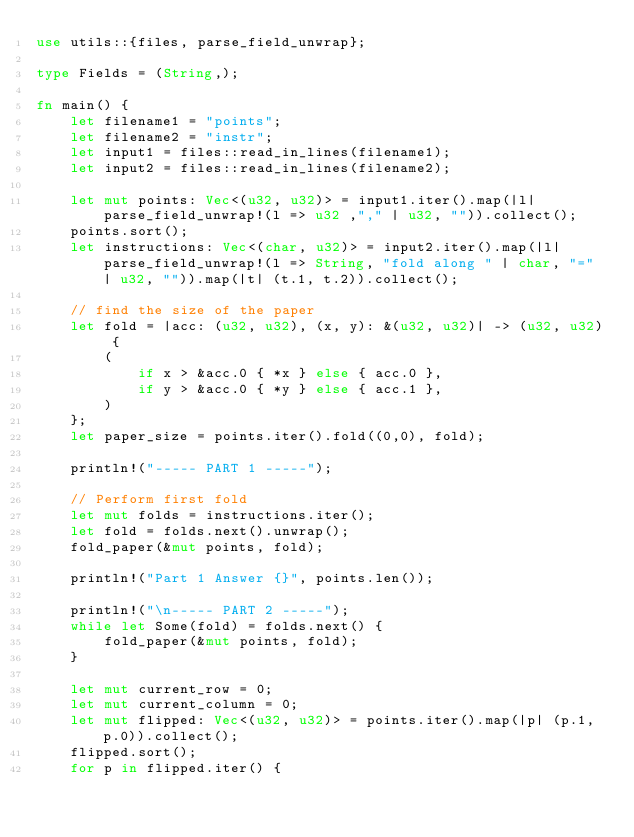<code> <loc_0><loc_0><loc_500><loc_500><_Rust_>use utils::{files, parse_field_unwrap};

type Fields = (String,);

fn main() {
    let filename1 = "points";
    let filename2 = "instr";
    let input1 = files::read_in_lines(filename1);
    let input2 = files::read_in_lines(filename2);

    let mut points: Vec<(u32, u32)> = input1.iter().map(|l| parse_field_unwrap!(l => u32 ,"," | u32, "")).collect();
    points.sort();
    let instructions: Vec<(char, u32)> = input2.iter().map(|l| parse_field_unwrap!(l => String, "fold along " | char, "=" | u32, "")).map(|t| (t.1, t.2)).collect();

    // find the size of the paper
    let fold = |acc: (u32, u32), (x, y): &(u32, u32)| -> (u32, u32) {
        (
            if x > &acc.0 { *x } else { acc.0 },
            if y > &acc.0 { *y } else { acc.1 },
        )
    };
    let paper_size = points.iter().fold((0,0), fold);

    println!("----- PART 1 -----");

    // Perform first fold
    let mut folds = instructions.iter();
    let fold = folds.next().unwrap();
    fold_paper(&mut points, fold);

    println!("Part 1 Answer {}", points.len());

    println!("\n----- PART 2 -----");
    while let Some(fold) = folds.next() {
        fold_paper(&mut points, fold);
    }

    let mut current_row = 0;
    let mut current_column = 0;
    let mut flipped: Vec<(u32, u32)> = points.iter().map(|p| (p.1, p.0)).collect();
    flipped.sort();
    for p in flipped.iter() {</code> 